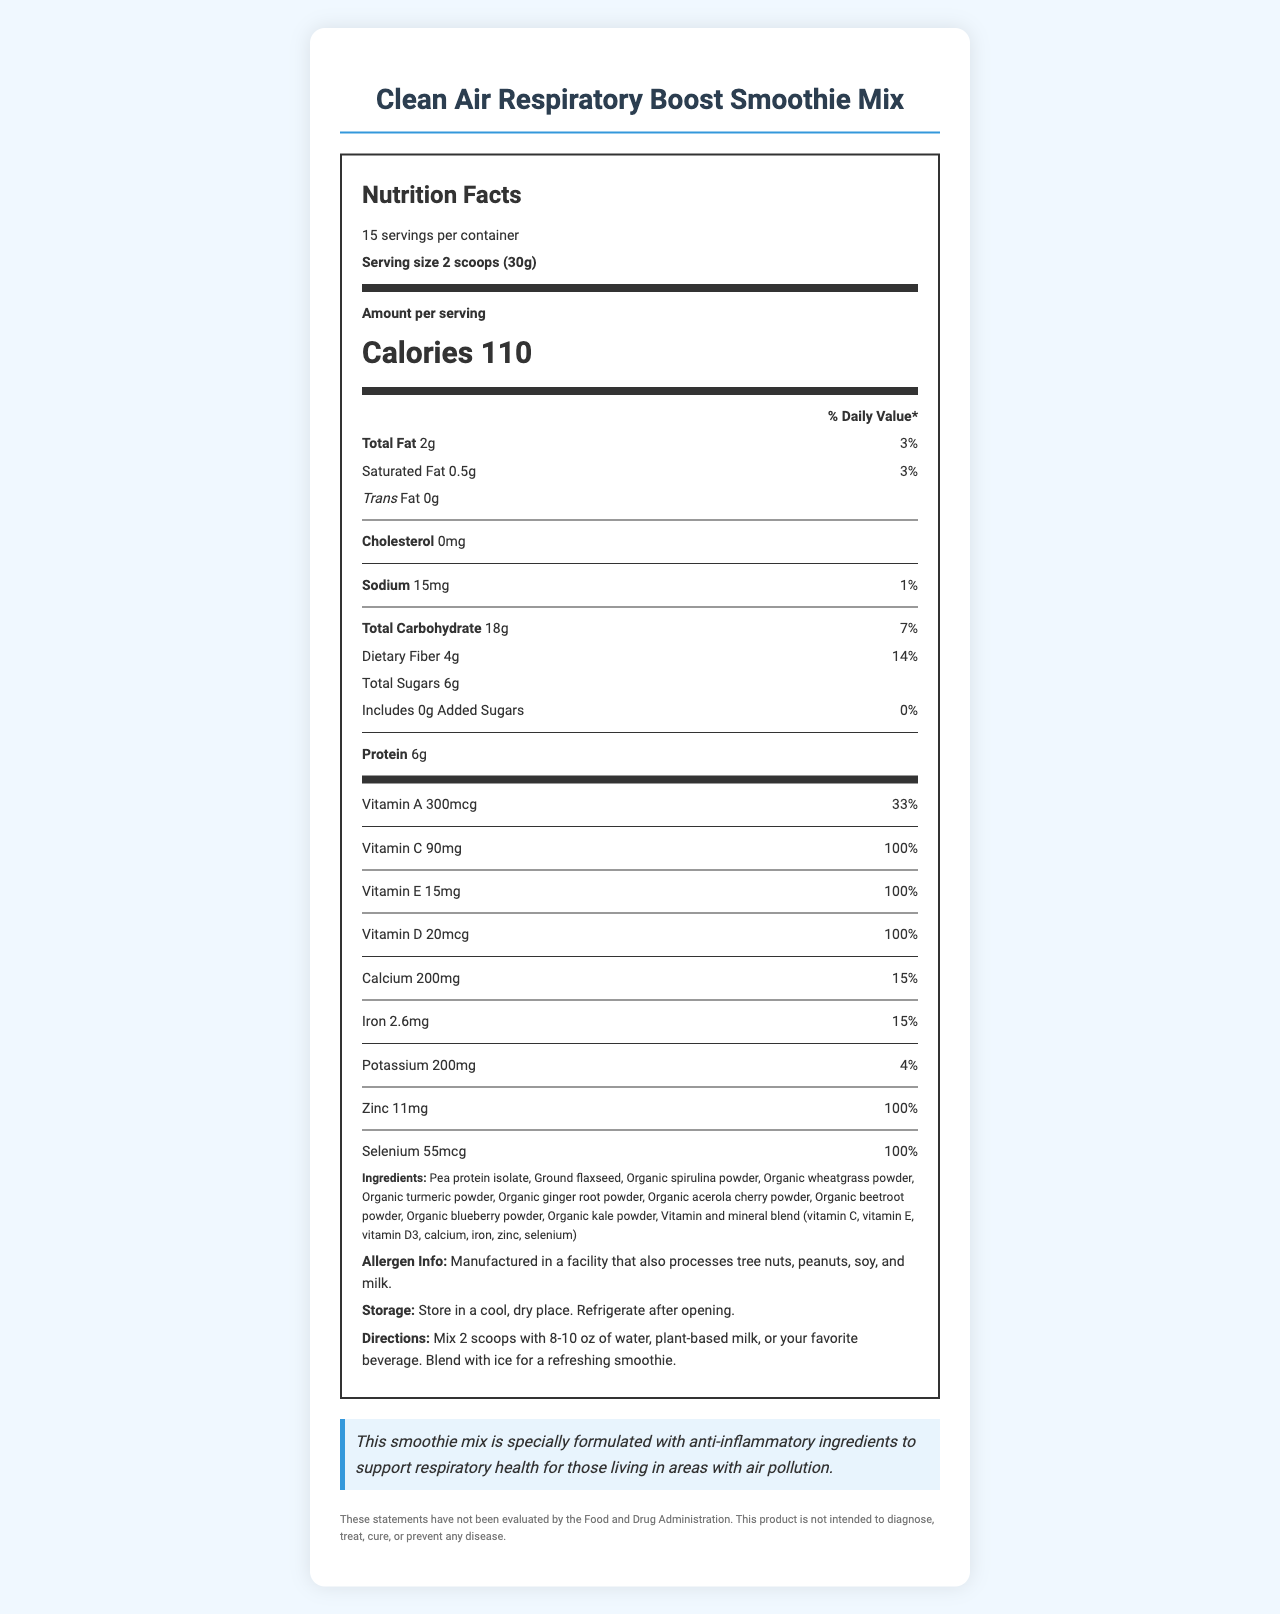What is the serving size of the Clean Air Respiratory Boost Smoothie Mix? The serving size is listed as 2 scoops (30g) under the "Serving size" section.
Answer: 2 scoops (30g) What is the calorie count per serving? The amount of calories per serving is provided next to "Calories" in bold in the "Amount per serving" section.
Answer: 110 calories How much protein does each serving contain? The protein content per serving is listed as 6g next to "Protein".
Answer: 6g Does the smoothie mix contain any added sugars? The label shows "Includes 0g Added Sugars", which indicates there are no added sugars.
Answer: No What is the major health claim made for the product? The health claim is provided in the health-claim section of the document.
Answer: This smoothie mix is specially formulated with anti-inflammatory ingredients to support respiratory health for those living in areas with air pollution. How many servings are there in each container? A. 12 B. 15 C. 18 D. 20 The number of servings per container is listed as 15 next to "servings per container".
Answer: B. 15 Which of these vitamins has a daily value percentage of 100% per serving? A. Vitamin A B. Vitamin C C. Vitamin D D. Vitamin B12 The daily value percentage for vitamins is listed next to each vitamin amount, and Vitamin D has a 100% daily value per serving.
Answer: C. Vitamin D Is the product manufactured in a nut-free facility? The allergen information states that the facility also processes tree nuts, peanuts, soy, and milk.
Answer: No Summarize the main idea of the document. This summary captures the central elements of the document, including nutritional facts, health claims, and usage instructions.
Answer: The document provides detailed nutritional information about the Clean Air Respiratory Boost Smoothie Mix, highlighting its health benefits for respiratory health, allergen information, ingredients, storage instructions, and usage directions. What percentage of daily value for calcium does each serving provide? The daily value percentage for calcium is listed as 15% next to the calcium amount.
Answer: 15% How much vitamin C is contained per serving? The vitamin C content per serving is listed as 90mg.
Answer: 90mg Which vitamin is not listed in the ingredients? A. Vitamin A B. Vitamin C C. Vitamin E D. Vitamin B12 Vitamin B12 is not mentioned in the list of vitamins in the nutrition facts.
Answer: D. Vitamin B12 What is the amount of iron per serving? The amount of iron per serving is listed as 2.6mg.
Answer: 2.6mg Can the product diagnose, treat, cure, or prevent any disease? The disclaimer at the bottom of the document states that the product is not intended to diagnose, treat, cure, or prevent any disease.
Answer: No What is the recommended storage condition for the product? The storage instructions are clearly mentioned in the document.
Answer: Store in a cool, dry place. Refrigerate after opening. Does the smoothie mix contain any cholesterol? It is mentioned in the document that the cholesterol amount is 0mg, indicating no cholesterol content.
Answer: No Where is the product recommended to be mixed with? The directions specify that the product should be mixed with 8-10 oz of water, plant-based milk, or your favorite beverage.
Answer: Water, plant-based milk, or your favorite beverage What is the price of the Clean Air Respiratory Boost Smoothie Mix? The document does not provide any information regarding the price of the product.
Answer: Not enough information 